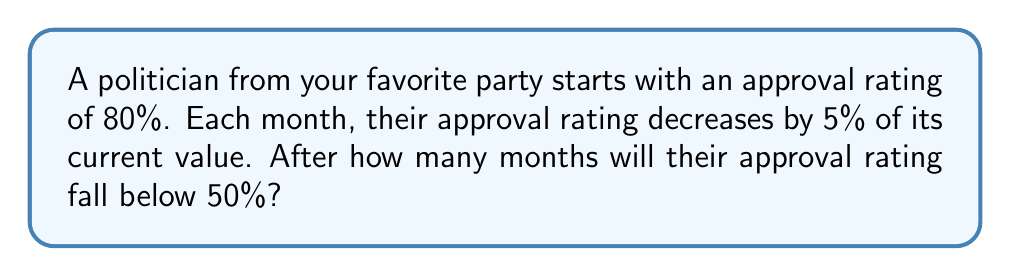Help me with this question. Let's approach this step-by-step:

1) We start with an initial approval rating of 80%, and each month it decreases by 5% of its current value.

2) This scenario describes exponential decay. The formula for exponential decay is:

   $$A(t) = A_0 \cdot (1-r)^t$$

   Where:
   $A(t)$ is the approval rating after time $t$
   $A_0$ is the initial approval rating
   $r$ is the decay rate per unit time
   $t$ is the number of time units (months in this case)

3) In our case:
   $A_0 = 80\%$
   $r = 5\% = 0.05$
   We want to find $t$ when $A(t) < 50\%$

4) Let's substitute these into our equation:

   $$50 > 80 \cdot (1-0.05)^t$$

5) Simplify:

   $$50 > 80 \cdot (0.95)^t$$

6) Divide both sides by 80:

   $$0.625 > (0.95)^t$$

7) Take the natural log of both sides:

   $$\ln(0.625) > t \cdot \ln(0.95)$$

8) Solve for $t$:

   $$t > \frac{\ln(0.625)}{\ln(0.95)} \approx 9.53$$

9) Since we're dealing with whole months, we need to round up to the next integer.
Answer: 10 months 